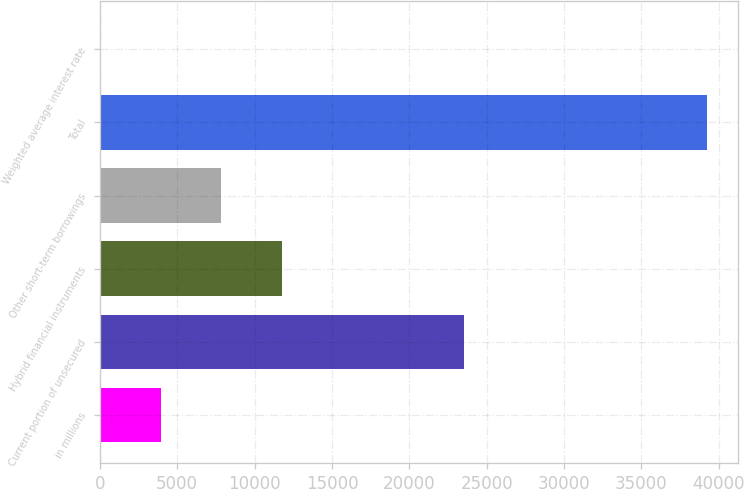Convert chart to OTSL. <chart><loc_0><loc_0><loc_500><loc_500><bar_chart><fcel>in millions<fcel>Current portion of unsecured<fcel>Hybrid financial instruments<fcel>Other short-term borrowings<fcel>Total<fcel>Weighted average interest rate<nl><fcel>3928.01<fcel>23528<fcel>11780.7<fcel>7854.34<fcel>39265<fcel>1.68<nl></chart> 